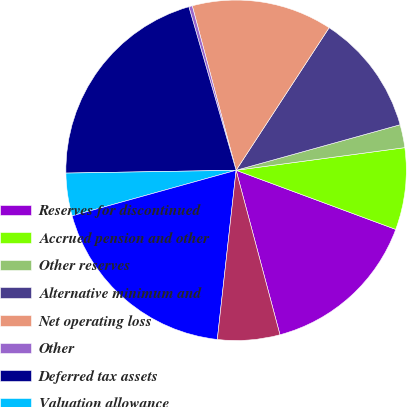Convert chart. <chart><loc_0><loc_0><loc_500><loc_500><pie_chart><fcel>Reserves for discontinued<fcel>Accrued pension and other<fcel>Other reserves<fcel>Alternative minimum and<fcel>Net operating loss<fcel>Other<fcel>Deferred tax assets<fcel>Valuation allowance<fcel>Deferred tax assets net of<fcel>Property plant and equipment<nl><fcel>15.21%<fcel>7.77%<fcel>2.19%<fcel>11.49%<fcel>13.35%<fcel>0.33%<fcel>20.79%<fcel>4.05%<fcel>18.93%<fcel>5.91%<nl></chart> 